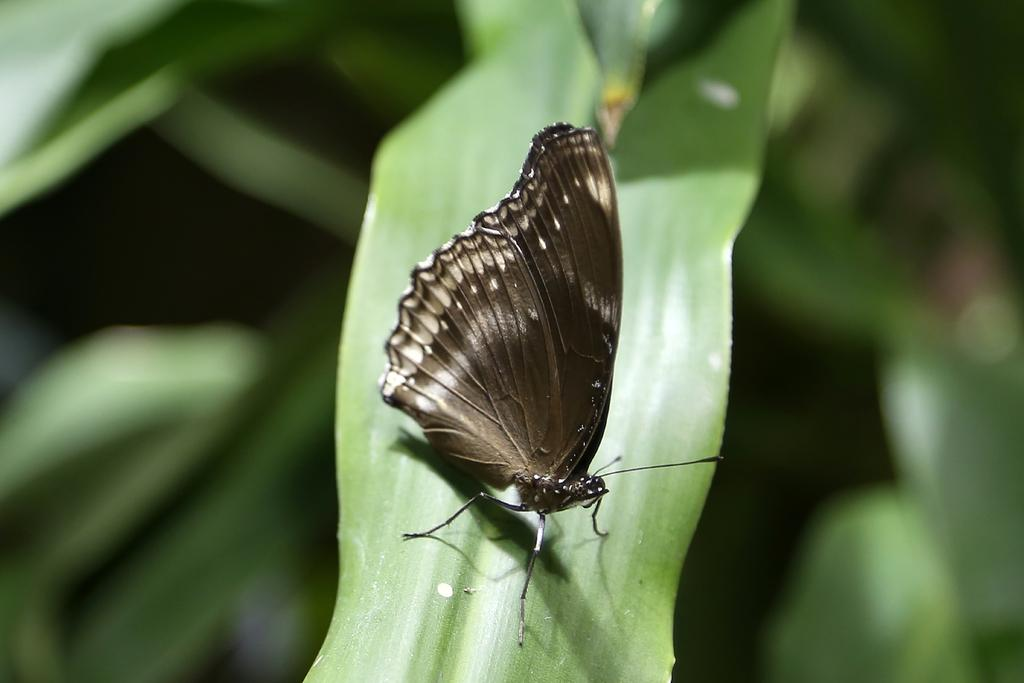What is the main subject of the image? There is a butterfly in the image. Where is the butterfly located? The butterfly is on a leaf. How many cherries are hanging from the sail in the image? There are no cherries or sails present in the image; it features a butterfly on a leaf. 